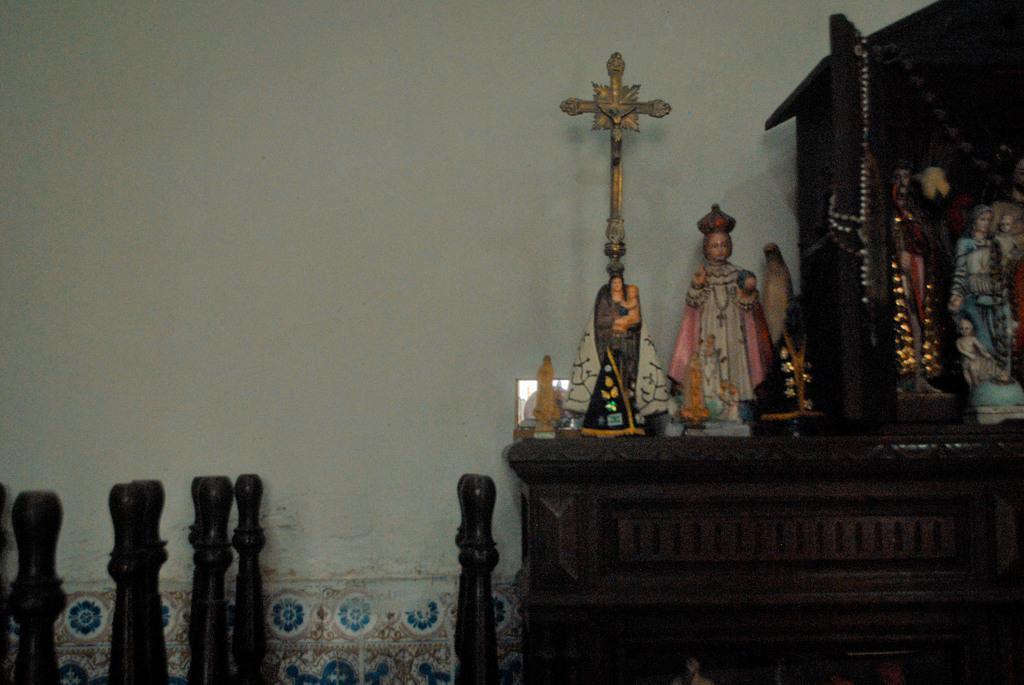Please provide a concise description of this image. On the right there are idols, cross and other objects on a desk. On the left there are some wooden objects. In the picture there is wall painted white. 